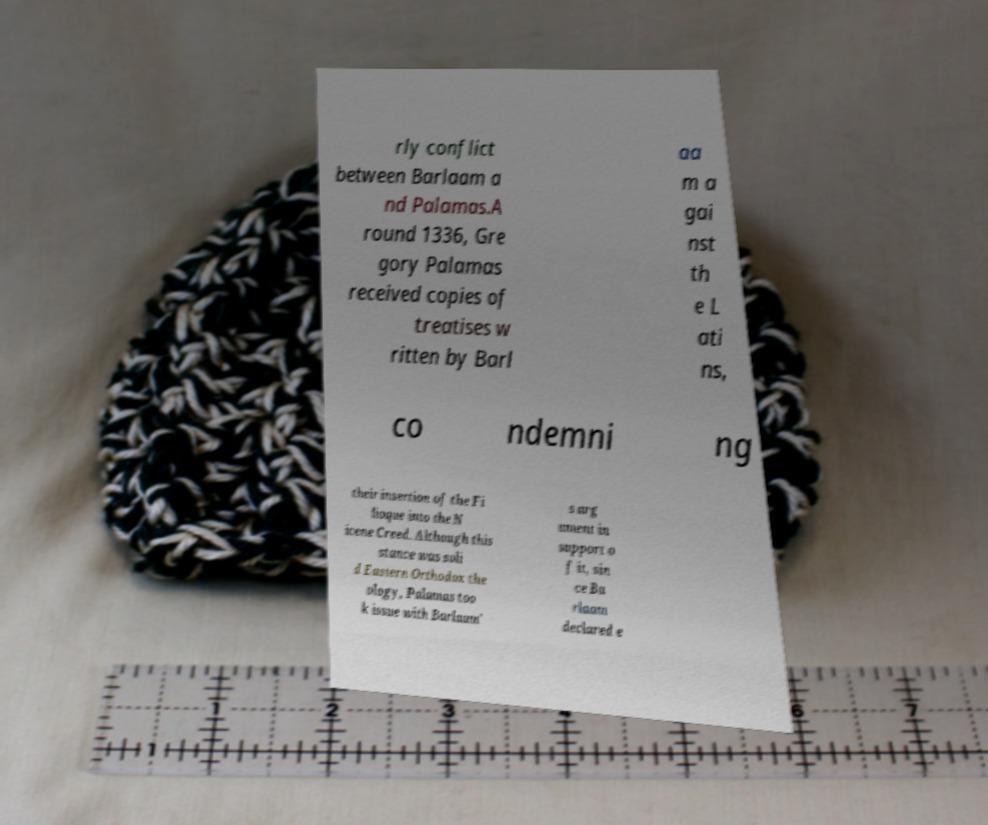Please read and relay the text visible in this image. What does it say? rly conflict between Barlaam a nd Palamas.A round 1336, Gre gory Palamas received copies of treatises w ritten by Barl aa m a gai nst th e L ati ns, co ndemni ng their insertion of the Fi lioque into the N icene Creed. Although this stance was soli d Eastern Orthodox the ology, Palamas too k issue with Barlaam' s arg ument in support o f it, sin ce Ba rlaam declared e 